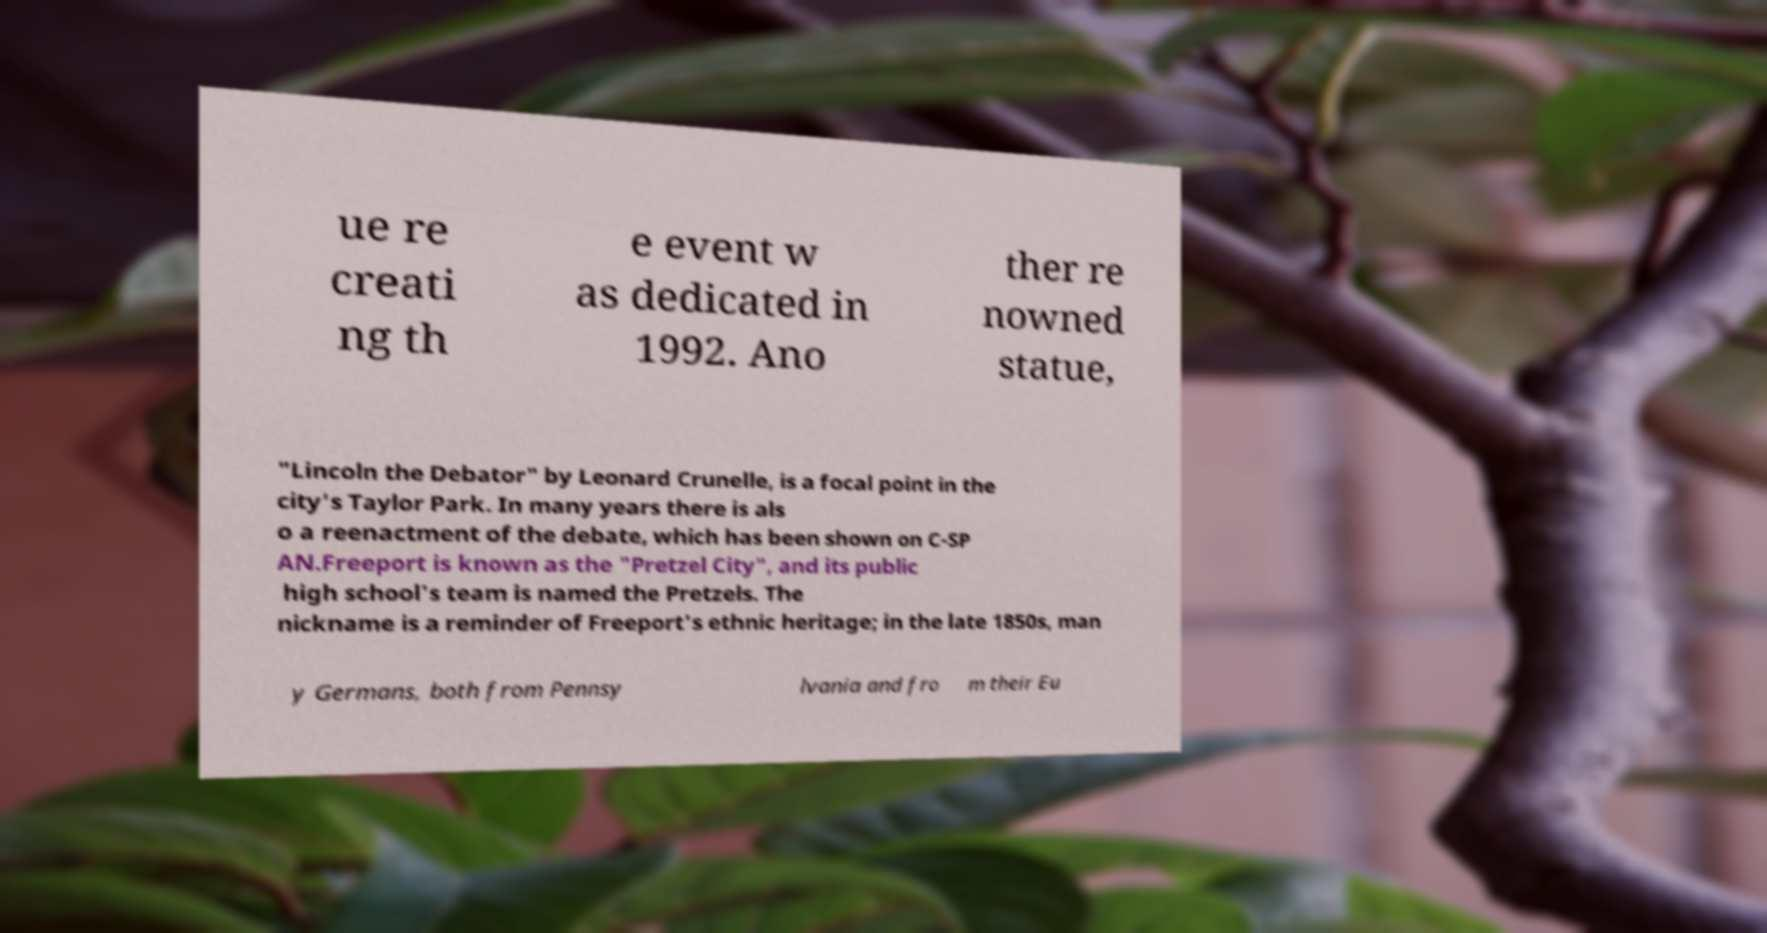Could you extract and type out the text from this image? ue re creati ng th e event w as dedicated in 1992. Ano ther re nowned statue, "Lincoln the Debator" by Leonard Crunelle, is a focal point in the city's Taylor Park. In many years there is als o a reenactment of the debate, which has been shown on C-SP AN.Freeport is known as the "Pretzel City", and its public high school's team is named the Pretzels. The nickname is a reminder of Freeport's ethnic heritage; in the late 1850s, man y Germans, both from Pennsy lvania and fro m their Eu 